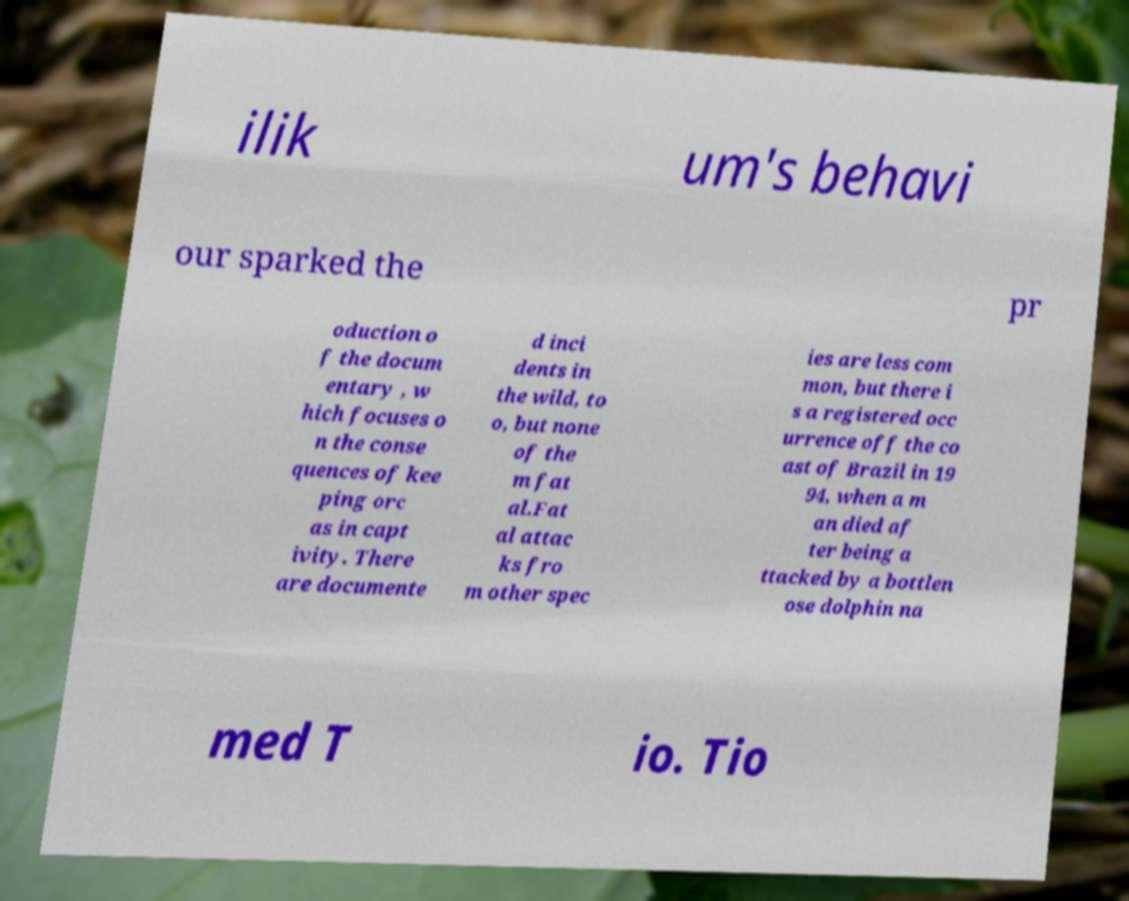Can you read and provide the text displayed in the image?This photo seems to have some interesting text. Can you extract and type it out for me? ilik um's behavi our sparked the pr oduction o f the docum entary , w hich focuses o n the conse quences of kee ping orc as in capt ivity. There are documente d inci dents in the wild, to o, but none of the m fat al.Fat al attac ks fro m other spec ies are less com mon, but there i s a registered occ urrence off the co ast of Brazil in 19 94, when a m an died af ter being a ttacked by a bottlen ose dolphin na med T io. Tio 